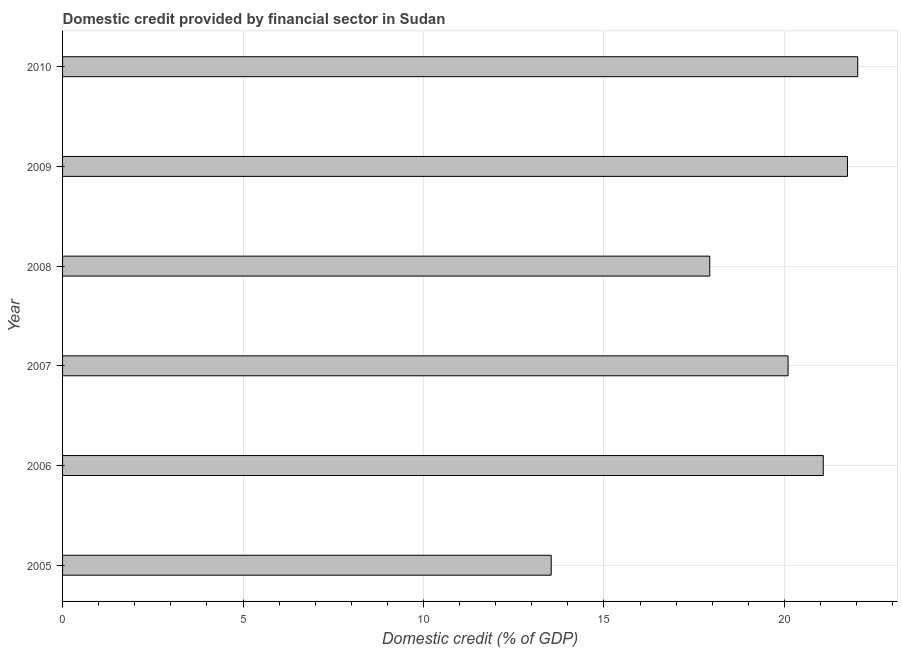Does the graph contain grids?
Give a very brief answer. Yes. What is the title of the graph?
Your response must be concise. Domestic credit provided by financial sector in Sudan. What is the label or title of the X-axis?
Ensure brevity in your answer.  Domestic credit (% of GDP). What is the domestic credit provided by financial sector in 2007?
Provide a succinct answer. 20.1. Across all years, what is the maximum domestic credit provided by financial sector?
Your answer should be very brief. 22.03. Across all years, what is the minimum domestic credit provided by financial sector?
Provide a short and direct response. 13.54. In which year was the domestic credit provided by financial sector maximum?
Provide a succinct answer. 2010. In which year was the domestic credit provided by financial sector minimum?
Provide a short and direct response. 2005. What is the sum of the domestic credit provided by financial sector?
Your answer should be compact. 116.42. What is the difference between the domestic credit provided by financial sector in 2005 and 2008?
Offer a very short reply. -4.39. What is the average domestic credit provided by financial sector per year?
Give a very brief answer. 19.4. What is the median domestic credit provided by financial sector?
Provide a short and direct response. 20.59. In how many years, is the domestic credit provided by financial sector greater than 6 %?
Offer a very short reply. 6. What is the ratio of the domestic credit provided by financial sector in 2005 to that in 2009?
Offer a terse response. 0.62. Is the domestic credit provided by financial sector in 2007 less than that in 2009?
Offer a very short reply. Yes. What is the difference between the highest and the second highest domestic credit provided by financial sector?
Provide a succinct answer. 0.28. What is the difference between the highest and the lowest domestic credit provided by financial sector?
Provide a succinct answer. 8.49. In how many years, is the domestic credit provided by financial sector greater than the average domestic credit provided by financial sector taken over all years?
Provide a short and direct response. 4. How many bars are there?
Your answer should be compact. 6. Are all the bars in the graph horizontal?
Make the answer very short. Yes. How many years are there in the graph?
Provide a succinct answer. 6. Are the values on the major ticks of X-axis written in scientific E-notation?
Ensure brevity in your answer.  No. What is the Domestic credit (% of GDP) in 2005?
Offer a very short reply. 13.54. What is the Domestic credit (% of GDP) of 2006?
Give a very brief answer. 21.08. What is the Domestic credit (% of GDP) in 2007?
Offer a terse response. 20.1. What is the Domestic credit (% of GDP) in 2008?
Ensure brevity in your answer.  17.93. What is the Domestic credit (% of GDP) of 2009?
Provide a short and direct response. 21.75. What is the Domestic credit (% of GDP) in 2010?
Ensure brevity in your answer.  22.03. What is the difference between the Domestic credit (% of GDP) in 2005 and 2006?
Offer a very short reply. -7.54. What is the difference between the Domestic credit (% of GDP) in 2005 and 2007?
Your response must be concise. -6.56. What is the difference between the Domestic credit (% of GDP) in 2005 and 2008?
Keep it short and to the point. -4.39. What is the difference between the Domestic credit (% of GDP) in 2005 and 2009?
Make the answer very short. -8.21. What is the difference between the Domestic credit (% of GDP) in 2005 and 2010?
Your answer should be very brief. -8.49. What is the difference between the Domestic credit (% of GDP) in 2006 and 2007?
Give a very brief answer. 0.97. What is the difference between the Domestic credit (% of GDP) in 2006 and 2008?
Keep it short and to the point. 3.14. What is the difference between the Domestic credit (% of GDP) in 2006 and 2009?
Your answer should be compact. -0.67. What is the difference between the Domestic credit (% of GDP) in 2006 and 2010?
Provide a short and direct response. -0.96. What is the difference between the Domestic credit (% of GDP) in 2007 and 2008?
Keep it short and to the point. 2.17. What is the difference between the Domestic credit (% of GDP) in 2007 and 2009?
Your answer should be compact. -1.64. What is the difference between the Domestic credit (% of GDP) in 2007 and 2010?
Your answer should be compact. -1.93. What is the difference between the Domestic credit (% of GDP) in 2008 and 2009?
Your answer should be very brief. -3.81. What is the difference between the Domestic credit (% of GDP) in 2008 and 2010?
Ensure brevity in your answer.  -4.1. What is the difference between the Domestic credit (% of GDP) in 2009 and 2010?
Your answer should be compact. -0.28. What is the ratio of the Domestic credit (% of GDP) in 2005 to that in 2006?
Your answer should be very brief. 0.64. What is the ratio of the Domestic credit (% of GDP) in 2005 to that in 2007?
Your response must be concise. 0.67. What is the ratio of the Domestic credit (% of GDP) in 2005 to that in 2008?
Your answer should be very brief. 0.76. What is the ratio of the Domestic credit (% of GDP) in 2005 to that in 2009?
Provide a succinct answer. 0.62. What is the ratio of the Domestic credit (% of GDP) in 2005 to that in 2010?
Offer a very short reply. 0.61. What is the ratio of the Domestic credit (% of GDP) in 2006 to that in 2007?
Provide a short and direct response. 1.05. What is the ratio of the Domestic credit (% of GDP) in 2006 to that in 2008?
Your response must be concise. 1.18. What is the ratio of the Domestic credit (% of GDP) in 2007 to that in 2008?
Offer a terse response. 1.12. What is the ratio of the Domestic credit (% of GDP) in 2007 to that in 2009?
Ensure brevity in your answer.  0.92. What is the ratio of the Domestic credit (% of GDP) in 2007 to that in 2010?
Give a very brief answer. 0.91. What is the ratio of the Domestic credit (% of GDP) in 2008 to that in 2009?
Keep it short and to the point. 0.82. What is the ratio of the Domestic credit (% of GDP) in 2008 to that in 2010?
Provide a succinct answer. 0.81. 